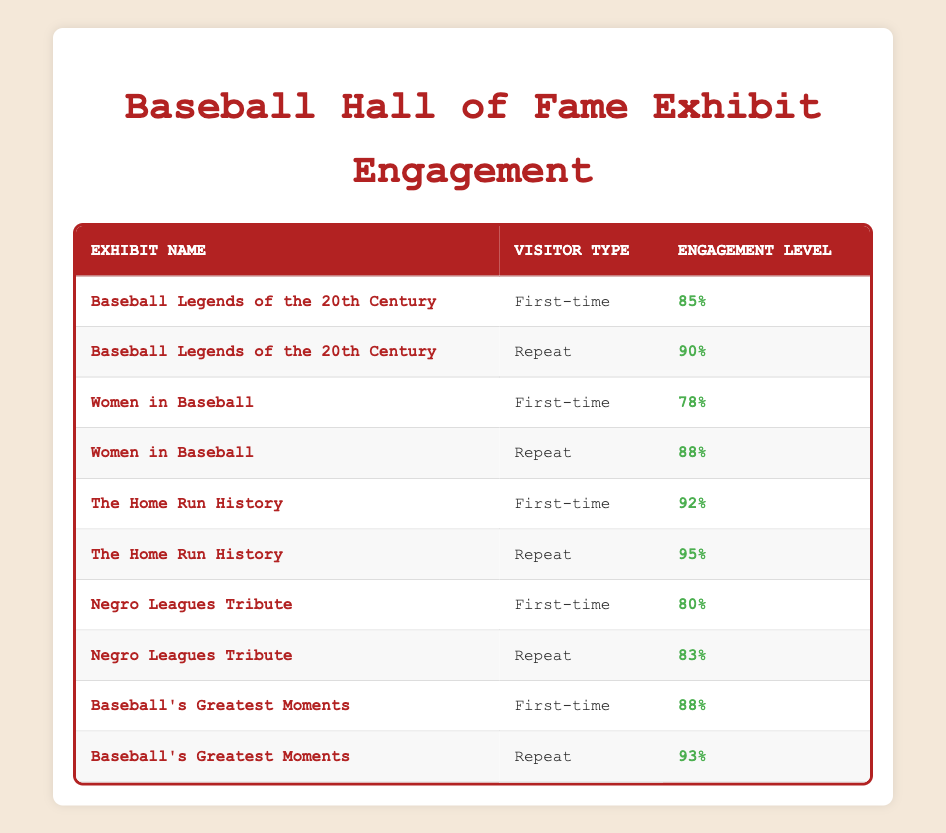What is the engagement level of first-time visitors for the "Women in Baseball" exhibit? The table shows that the engagement level for first-time visitors is 78% for the "Women in Baseball" exhibit, directly found in one of the rows.
Answer: 78% What engagement level do repeat visitors have for "Baseball's Greatest Moments"? According to the table, repeat visitors have an engagement level of 93% for the "Baseball's Greatest Moments" exhibit, which can be seen in the corresponding row.
Answer: 93% Which exhibit has the highest engagement level for repeat visitors? By examining the engagement levels of repeat visitors across all exhibits, "The Home Run History" has the highest level at 95%, found in the respective row.
Answer: 95% What is the average engagement level for first-time visitors across all exhibits? The engagement levels for first-time visitors are 85, 78, 92, 80, and 88. Summing these levels gives 423, and dividing by 5 (the number of exhibits) results in an average engagement level of 84.6%.
Answer: 84.6% Is the engagement level for first-time visitors consistently lower than for repeat visitors? Looking at each pair of engagement levels for first-time and repeat visitors, it is observed that first-time levels are lower for all exhibits except "Negro Leagues Tribute" where the difference is minimal. Therefore, the answer is mostly yes, indicating a trend of first-time levels being lower.
Answer: Yes How much higher is the engagement level for repeat visitors compared to first-time visitors for the "Negro Leagues Tribute"? The engagement level for repeat visitors is 83%, and for first-time visitors, it is 80%. The difference is calculated as 83 - 80 = 3, showing that repeat visitors engage 3 percentage points more.
Answer: 3 In which exhibit do visitors show the greatest difference in engagement levels between first-time and repeat individuals? By comparing the engagement levels, "The Home Run History" shows a difference of 3% (95% - 92%) for repeat versus first-time visitors, which is the greatest difference when examined for all exhibits.
Answer: The Home Run History Is it true that first-time visitors have a higher engagement level than 80% for any exhibit? Reviewing the engagement levels for first-time visitors, only "The Home Run History" (92%) and "Baseball's Greatest Moments" (88%) exceed 80%. Thus, the statement is true, as there are two exhibits where this holds true.
Answer: Yes 